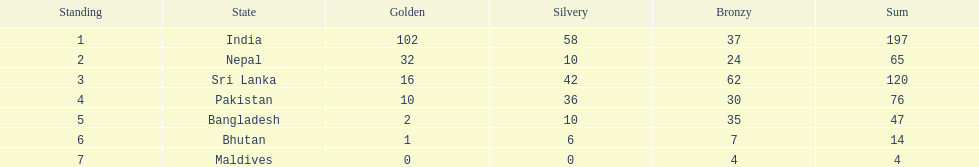What was the number of silver medals won by pakistan? 36. 